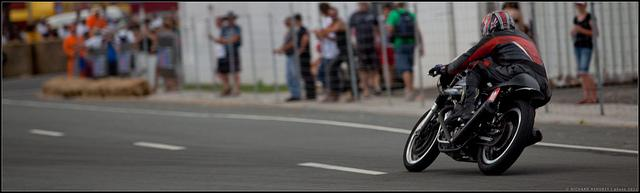Why is the rider's head covered?

Choices:
A) fashion
B) protection
C) religion
D) warmth protection 